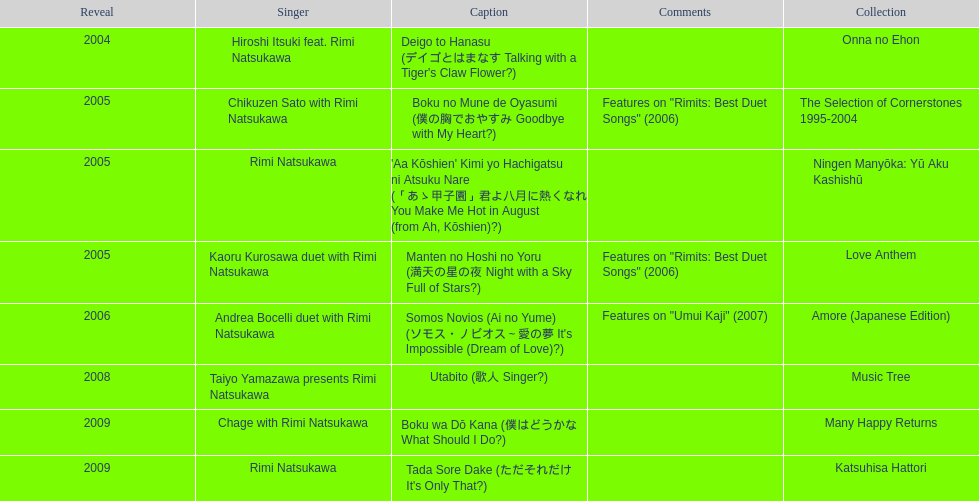What is the number of albums released with the artist rimi natsukawa? 8. 